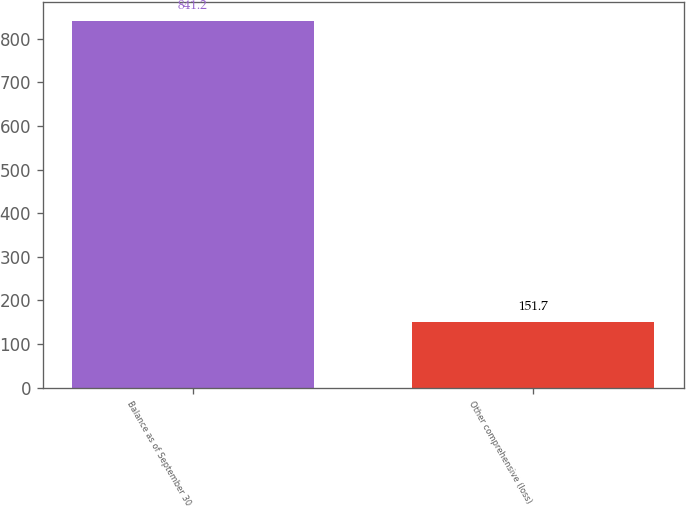Convert chart. <chart><loc_0><loc_0><loc_500><loc_500><bar_chart><fcel>Balance as of September 30<fcel>Other comprehensive (loss)<nl><fcel>841.2<fcel>151.7<nl></chart> 